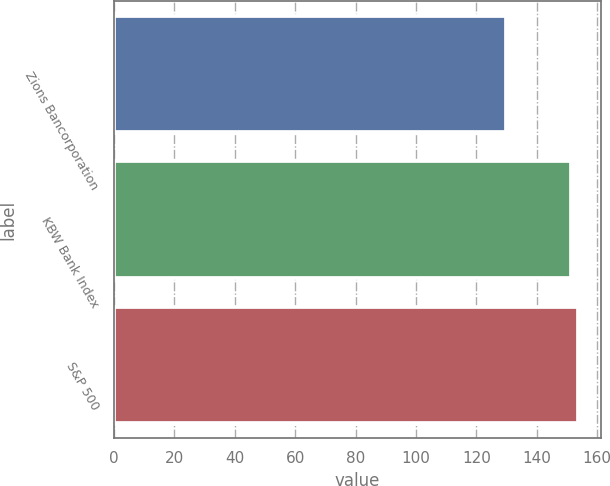Convert chart. <chart><loc_0><loc_0><loc_500><loc_500><bar_chart><fcel>Zions Bancorporation<fcel>KBW Bank Index<fcel>S&P 500<nl><fcel>129.8<fcel>151.4<fcel>153.67<nl></chart> 